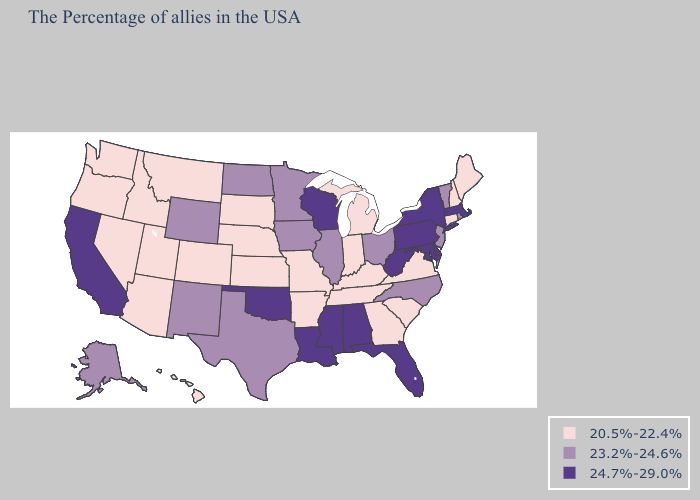Does West Virginia have the highest value in the USA?
Keep it brief. Yes. Among the states that border South Dakota , which have the lowest value?
Short answer required. Nebraska, Montana. Among the states that border Michigan , does Wisconsin have the highest value?
Give a very brief answer. Yes. What is the highest value in states that border West Virginia?
Keep it brief. 24.7%-29.0%. What is the highest value in the USA?
Keep it brief. 24.7%-29.0%. Does Pennsylvania have the same value as Nevada?
Answer briefly. No. Name the states that have a value in the range 24.7%-29.0%?
Concise answer only. Massachusetts, New York, Delaware, Maryland, Pennsylvania, West Virginia, Florida, Alabama, Wisconsin, Mississippi, Louisiana, Oklahoma, California. Among the states that border Nebraska , which have the highest value?
Give a very brief answer. Iowa, Wyoming. Does Illinois have a lower value than Delaware?
Answer briefly. Yes. What is the value of New Jersey?
Be succinct. 23.2%-24.6%. What is the lowest value in states that border Wisconsin?
Be succinct. 20.5%-22.4%. Which states have the highest value in the USA?
Give a very brief answer. Massachusetts, New York, Delaware, Maryland, Pennsylvania, West Virginia, Florida, Alabama, Wisconsin, Mississippi, Louisiana, Oklahoma, California. What is the value of West Virginia?
Keep it brief. 24.7%-29.0%. Name the states that have a value in the range 23.2%-24.6%?
Be succinct. Rhode Island, Vermont, New Jersey, North Carolina, Ohio, Illinois, Minnesota, Iowa, Texas, North Dakota, Wyoming, New Mexico, Alaska. What is the lowest value in states that border Arizona?
Give a very brief answer. 20.5%-22.4%. 